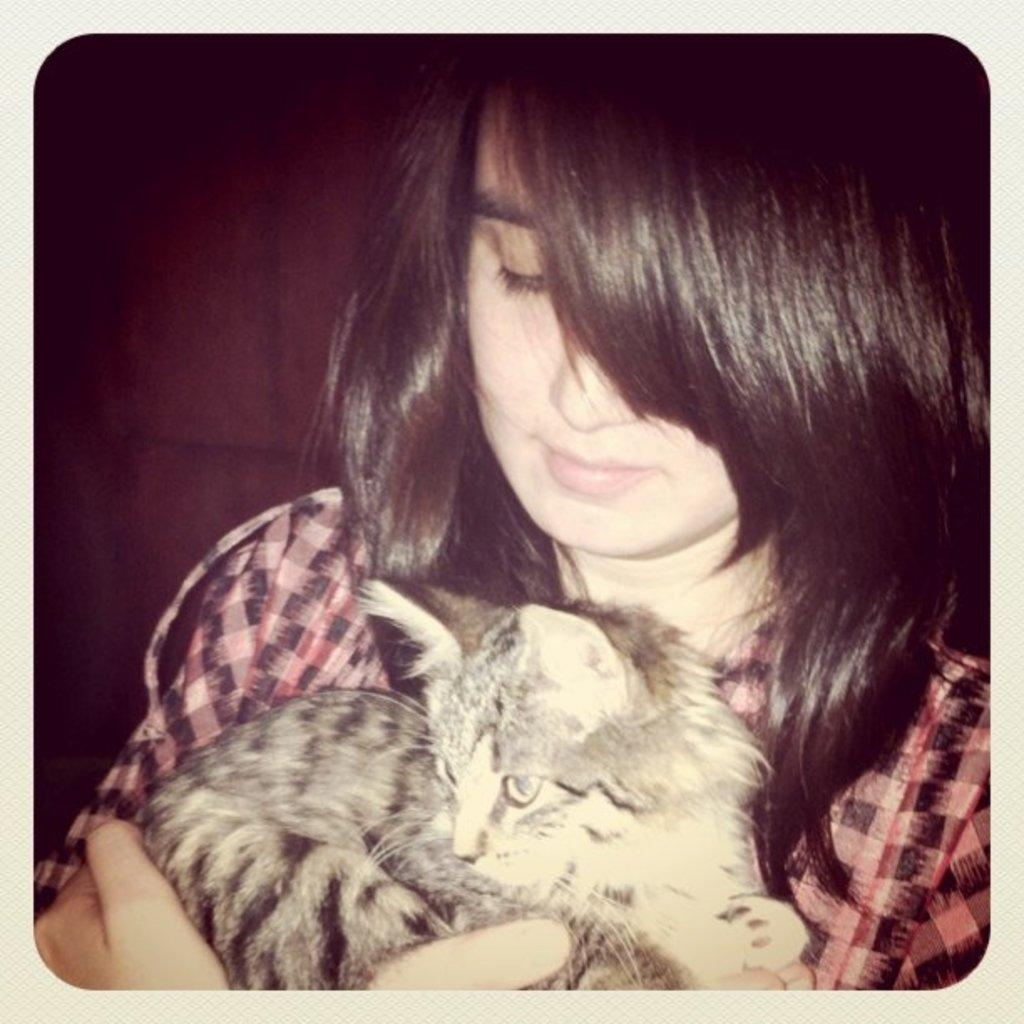Who is the main subject in the image? There is a woman in the image. What is the woman wearing? The woman is wearing a dress. What is the woman holding in her hands? The woman is holding a cat in her hands. What type of collar is the woman wearing in the image? The woman is not wearing a collar in the image; she is wearing a dress. 